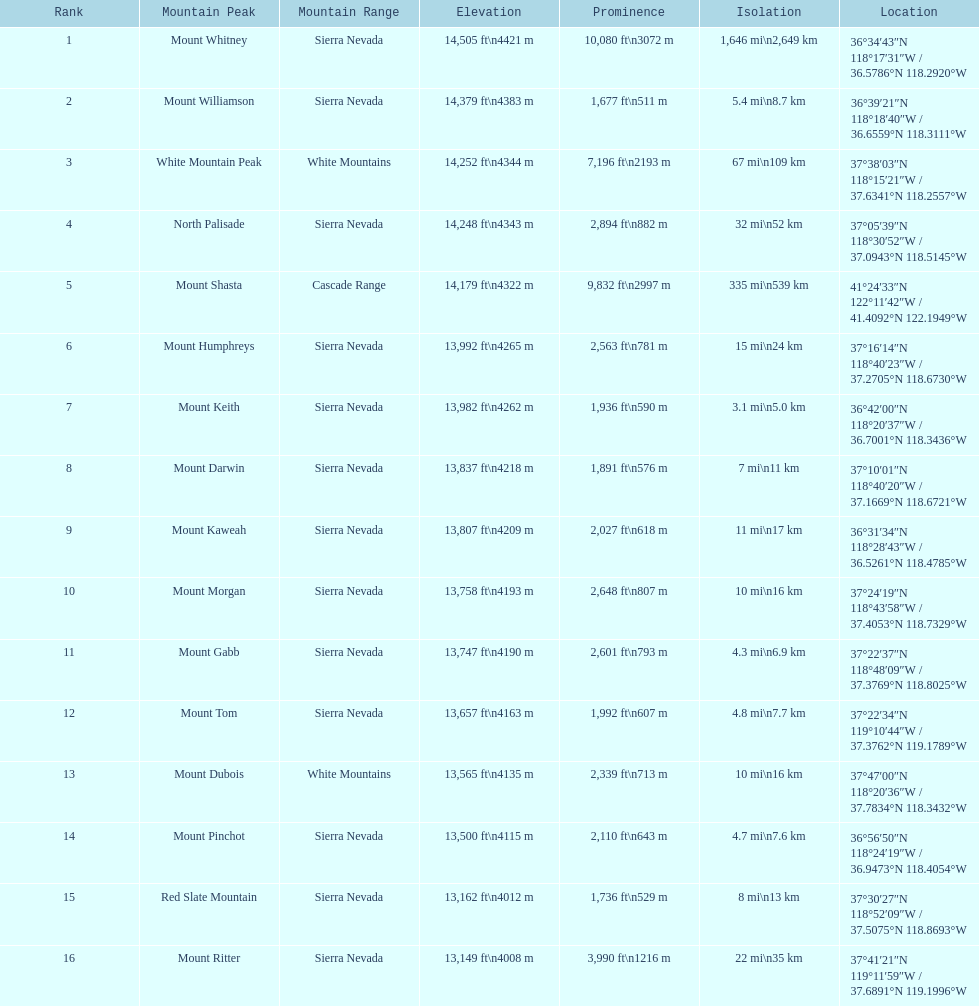What is the next highest mountain peak after north palisade? Mount Shasta. 